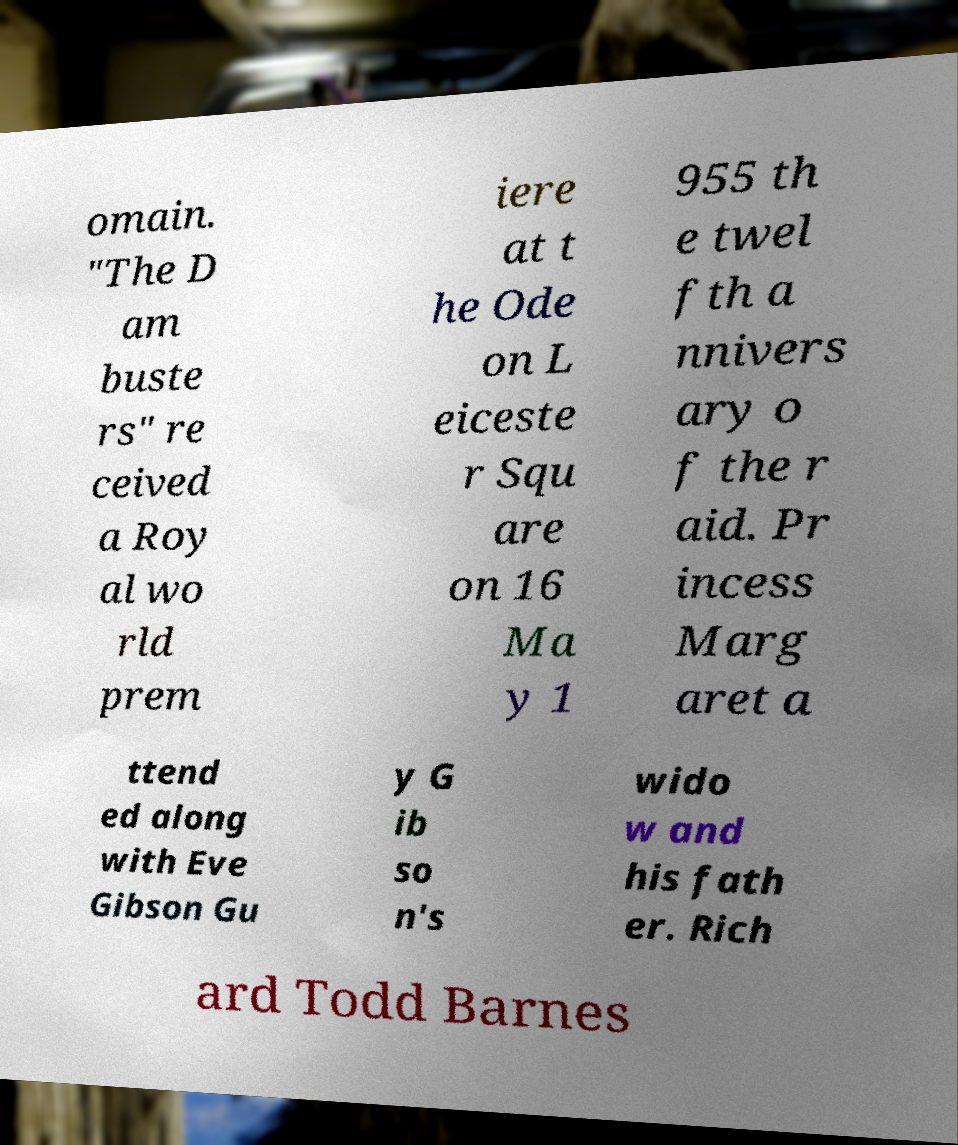What messages or text are displayed in this image? I need them in a readable, typed format. omain. "The D am buste rs" re ceived a Roy al wo rld prem iere at t he Ode on L eiceste r Squ are on 16 Ma y 1 955 th e twel fth a nnivers ary o f the r aid. Pr incess Marg aret a ttend ed along with Eve Gibson Gu y G ib so n's wido w and his fath er. Rich ard Todd Barnes 